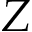Convert formula to latex. <formula><loc_0><loc_0><loc_500><loc_500>Z</formula> 